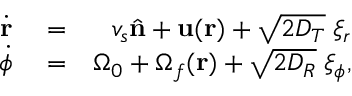<formula> <loc_0><loc_0><loc_500><loc_500>\begin{array} { r l r } { \dot { \mathbf r } } & = } & { v _ { s } \hat { \mathbf n } + u ( r ) + \sqrt { 2 D _ { T } } \, \xi _ { r } } \\ { \dot { \phi } } & = } & { \Omega _ { 0 } + \Omega _ { f } ( \mathbf r ) + \sqrt { 2 D _ { R } } \, \xi _ { \phi } , } \end{array}</formula> 